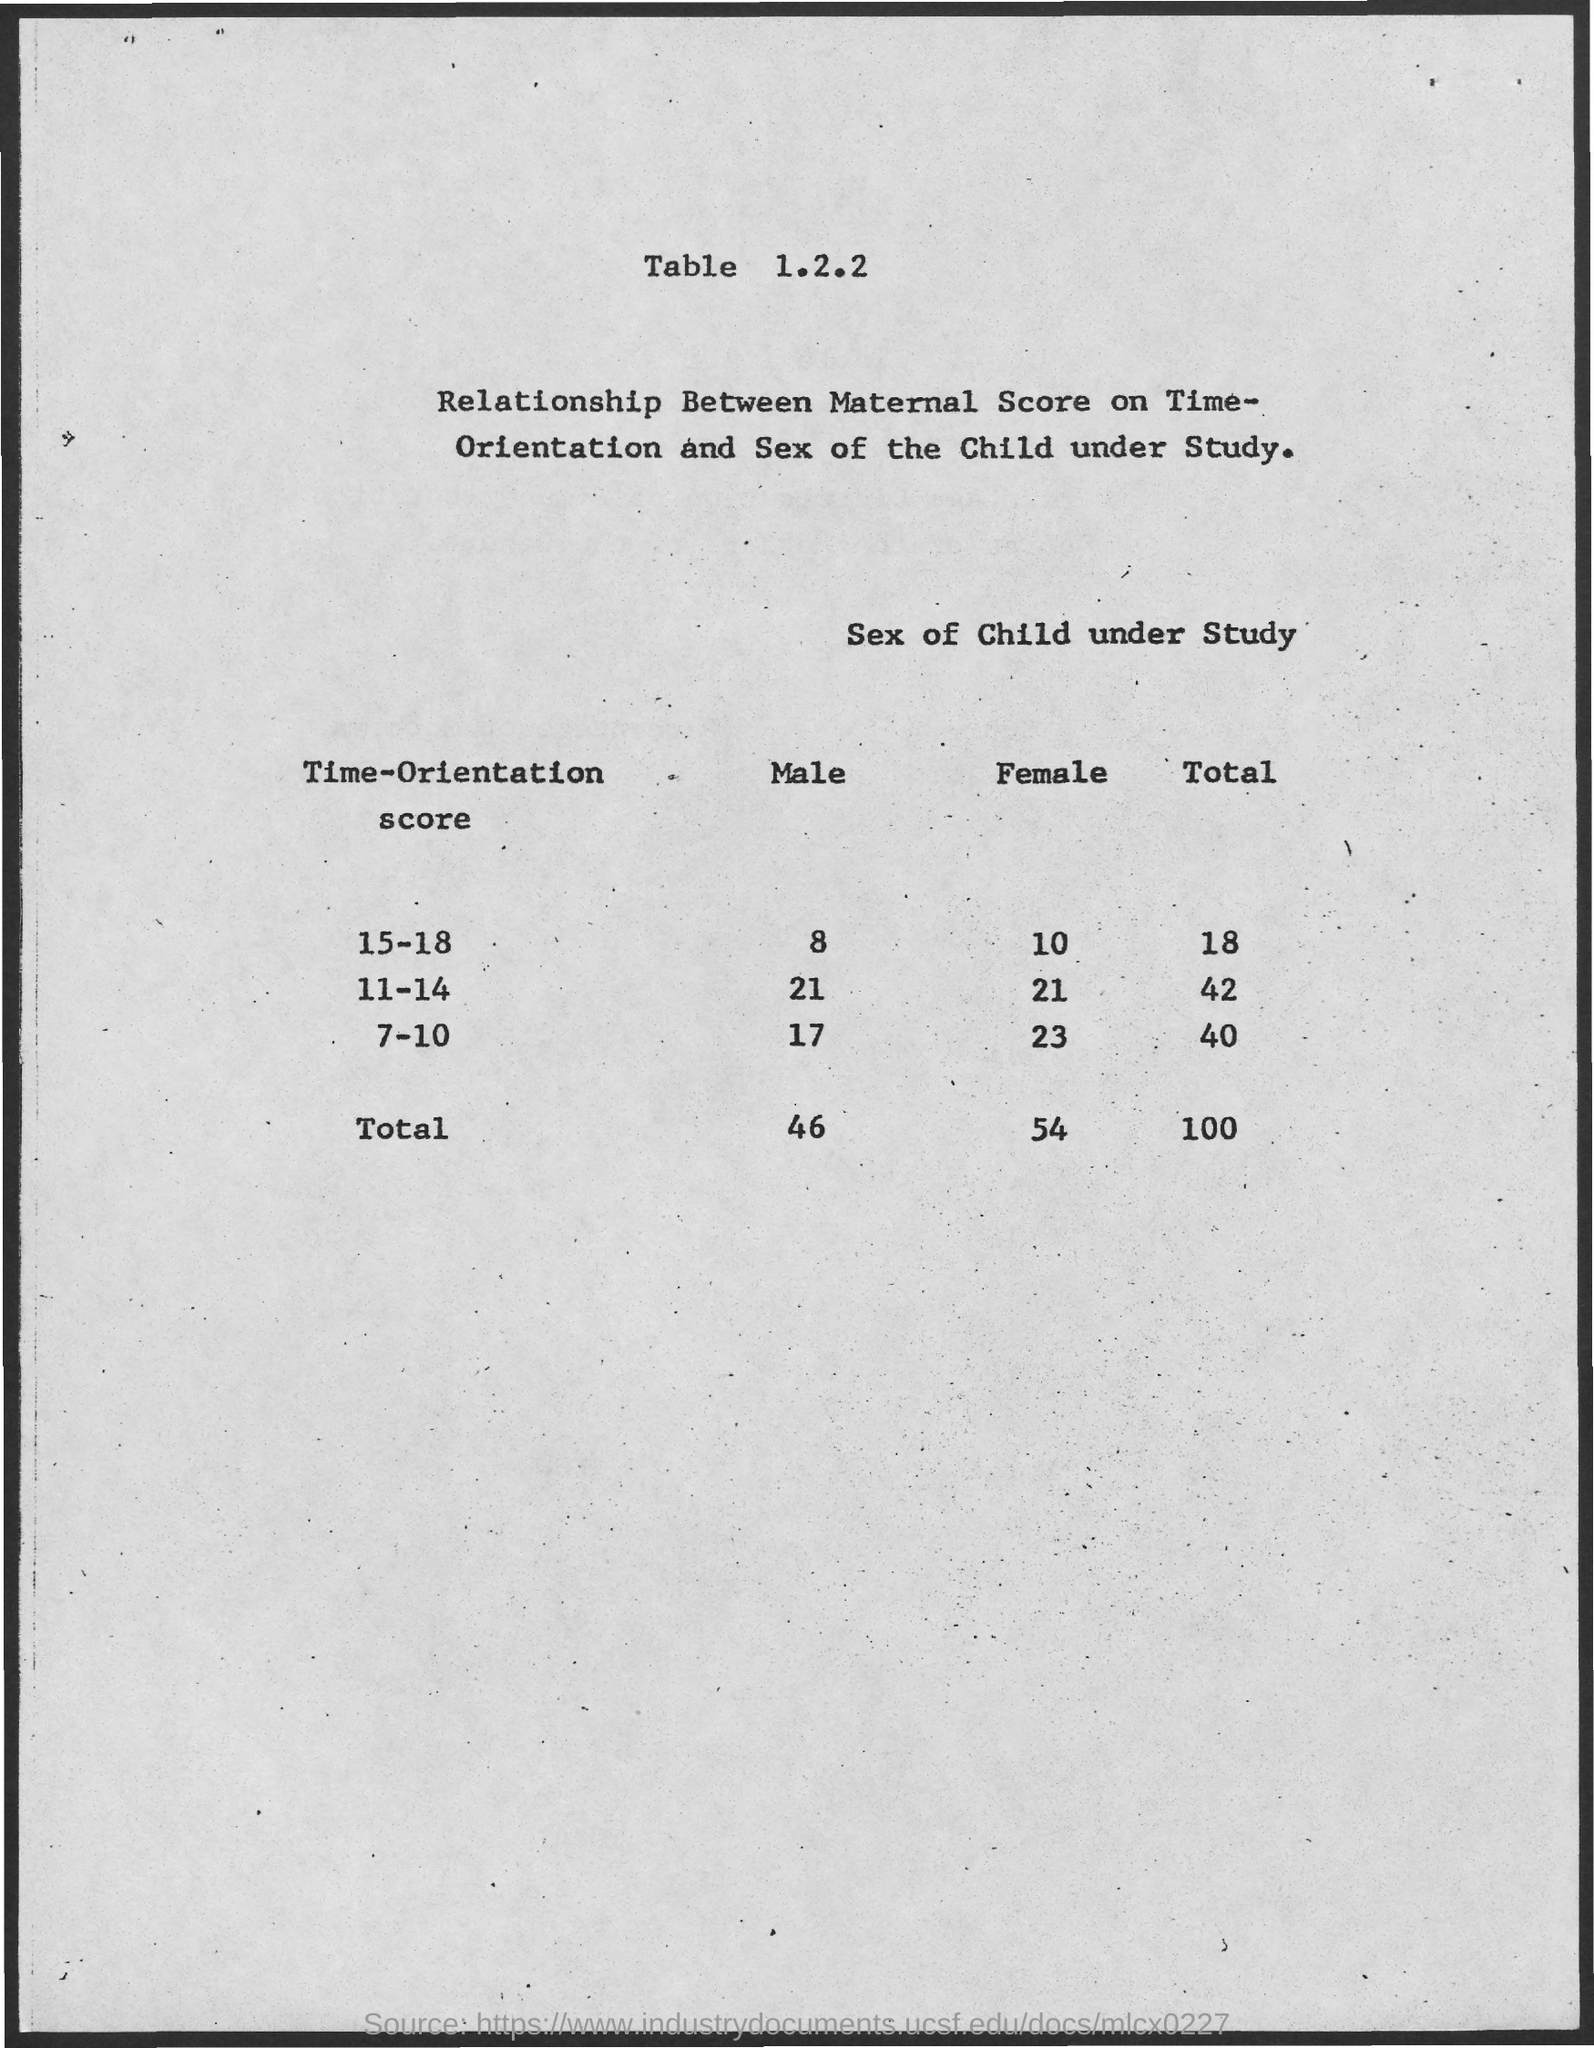What is the table number?
Your response must be concise. 1.2.2. How many males under time-orientation score of 15-18?
Offer a terse response. 8. How many females under time-orientation score of 7-10?
Keep it short and to the point. 23. 